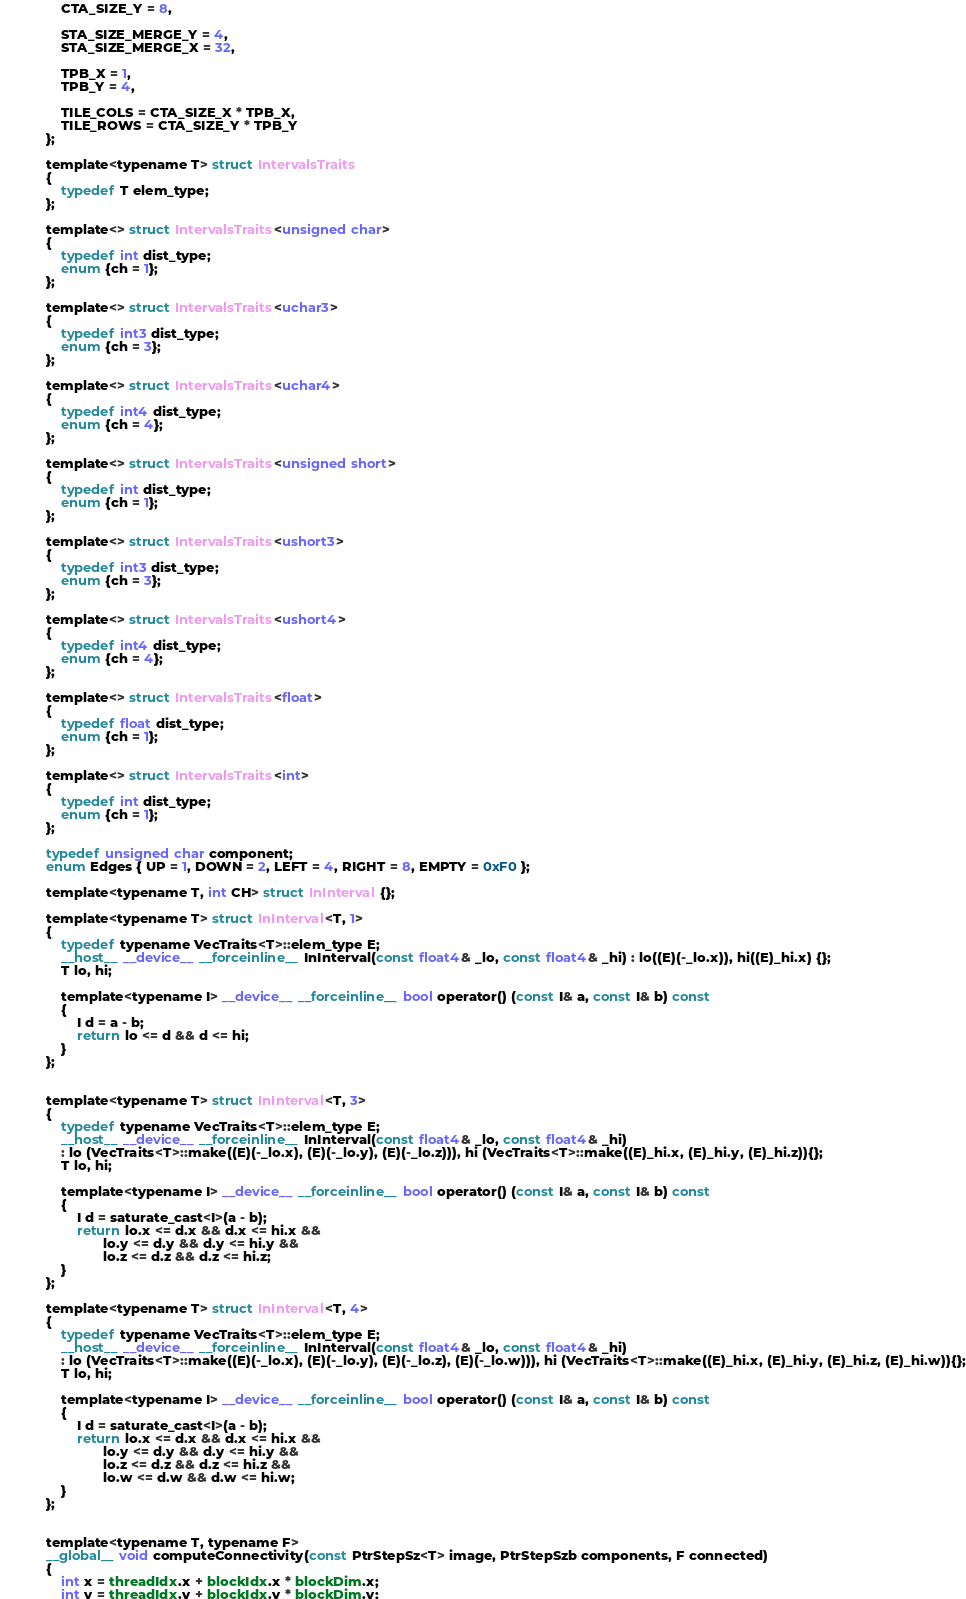<code> <loc_0><loc_0><loc_500><loc_500><_Cuda_>            CTA_SIZE_Y = 8,

            STA_SIZE_MERGE_Y = 4,
            STA_SIZE_MERGE_X = 32,

            TPB_X = 1,
            TPB_Y = 4,

            TILE_COLS = CTA_SIZE_X * TPB_X,
            TILE_ROWS = CTA_SIZE_Y * TPB_Y
        };

        template<typename T> struct IntervalsTraits
        {
            typedef T elem_type;
        };

        template<> struct IntervalsTraits<unsigned char>
        {
            typedef int dist_type;
            enum {ch = 1};
        };

        template<> struct IntervalsTraits<uchar3>
        {
            typedef int3 dist_type;
            enum {ch = 3};
        };

        template<> struct IntervalsTraits<uchar4>
        {
            typedef int4 dist_type;
            enum {ch = 4};
        };

        template<> struct IntervalsTraits<unsigned short>
        {
            typedef int dist_type;
            enum {ch = 1};
        };

        template<> struct IntervalsTraits<ushort3>
        {
            typedef int3 dist_type;
            enum {ch = 3};
        };

        template<> struct IntervalsTraits<ushort4>
        {
            typedef int4 dist_type;
            enum {ch = 4};
        };

        template<> struct IntervalsTraits<float>
        {
            typedef float dist_type;
            enum {ch = 1};
        };

        template<> struct IntervalsTraits<int>
        {
            typedef int dist_type;
            enum {ch = 1};
        };

        typedef unsigned char component;
        enum Edges { UP = 1, DOWN = 2, LEFT = 4, RIGHT = 8, EMPTY = 0xF0 };

        template<typename T, int CH> struct InInterval {};

        template<typename T> struct InInterval<T, 1>
        {
            typedef typename VecTraits<T>::elem_type E;
            __host__ __device__ __forceinline__ InInterval(const float4& _lo, const float4& _hi) : lo((E)(-_lo.x)), hi((E)_hi.x) {};
            T lo, hi;

            template<typename I> __device__ __forceinline__ bool operator() (const I& a, const I& b) const
            {
                I d = a - b;
                return lo <= d && d <= hi;
            }
        };


        template<typename T> struct InInterval<T, 3>
        {
            typedef typename VecTraits<T>::elem_type E;
            __host__ __device__ __forceinline__ InInterval(const float4& _lo, const float4& _hi)
            : lo (VecTraits<T>::make((E)(-_lo.x), (E)(-_lo.y), (E)(-_lo.z))), hi (VecTraits<T>::make((E)_hi.x, (E)_hi.y, (E)_hi.z)){};
            T lo, hi;

            template<typename I> __device__ __forceinline__ bool operator() (const I& a, const I& b) const
            {
                I d = saturate_cast<I>(a - b);
                return lo.x <= d.x && d.x <= hi.x &&
                       lo.y <= d.y && d.y <= hi.y &&
                       lo.z <= d.z && d.z <= hi.z;
            }
        };

        template<typename T> struct InInterval<T, 4>
        {
            typedef typename VecTraits<T>::elem_type E;
            __host__ __device__ __forceinline__ InInterval(const float4& _lo, const float4& _hi)
            : lo (VecTraits<T>::make((E)(-_lo.x), (E)(-_lo.y), (E)(-_lo.z), (E)(-_lo.w))), hi (VecTraits<T>::make((E)_hi.x, (E)_hi.y, (E)_hi.z, (E)_hi.w)){};
            T lo, hi;

            template<typename I> __device__ __forceinline__ bool operator() (const I& a, const I& b) const
            {
                I d = saturate_cast<I>(a - b);
                return lo.x <= d.x && d.x <= hi.x &&
                       lo.y <= d.y && d.y <= hi.y &&
                       lo.z <= d.z && d.z <= hi.z &&
                       lo.w <= d.w && d.w <= hi.w;
            }
        };


        template<typename T, typename F>
        __global__ void computeConnectivity(const PtrStepSz<T> image, PtrStepSzb components, F connected)
        {
            int x = threadIdx.x + blockIdx.x * blockDim.x;
            int y = threadIdx.y + blockIdx.y * blockDim.y;
</code> 